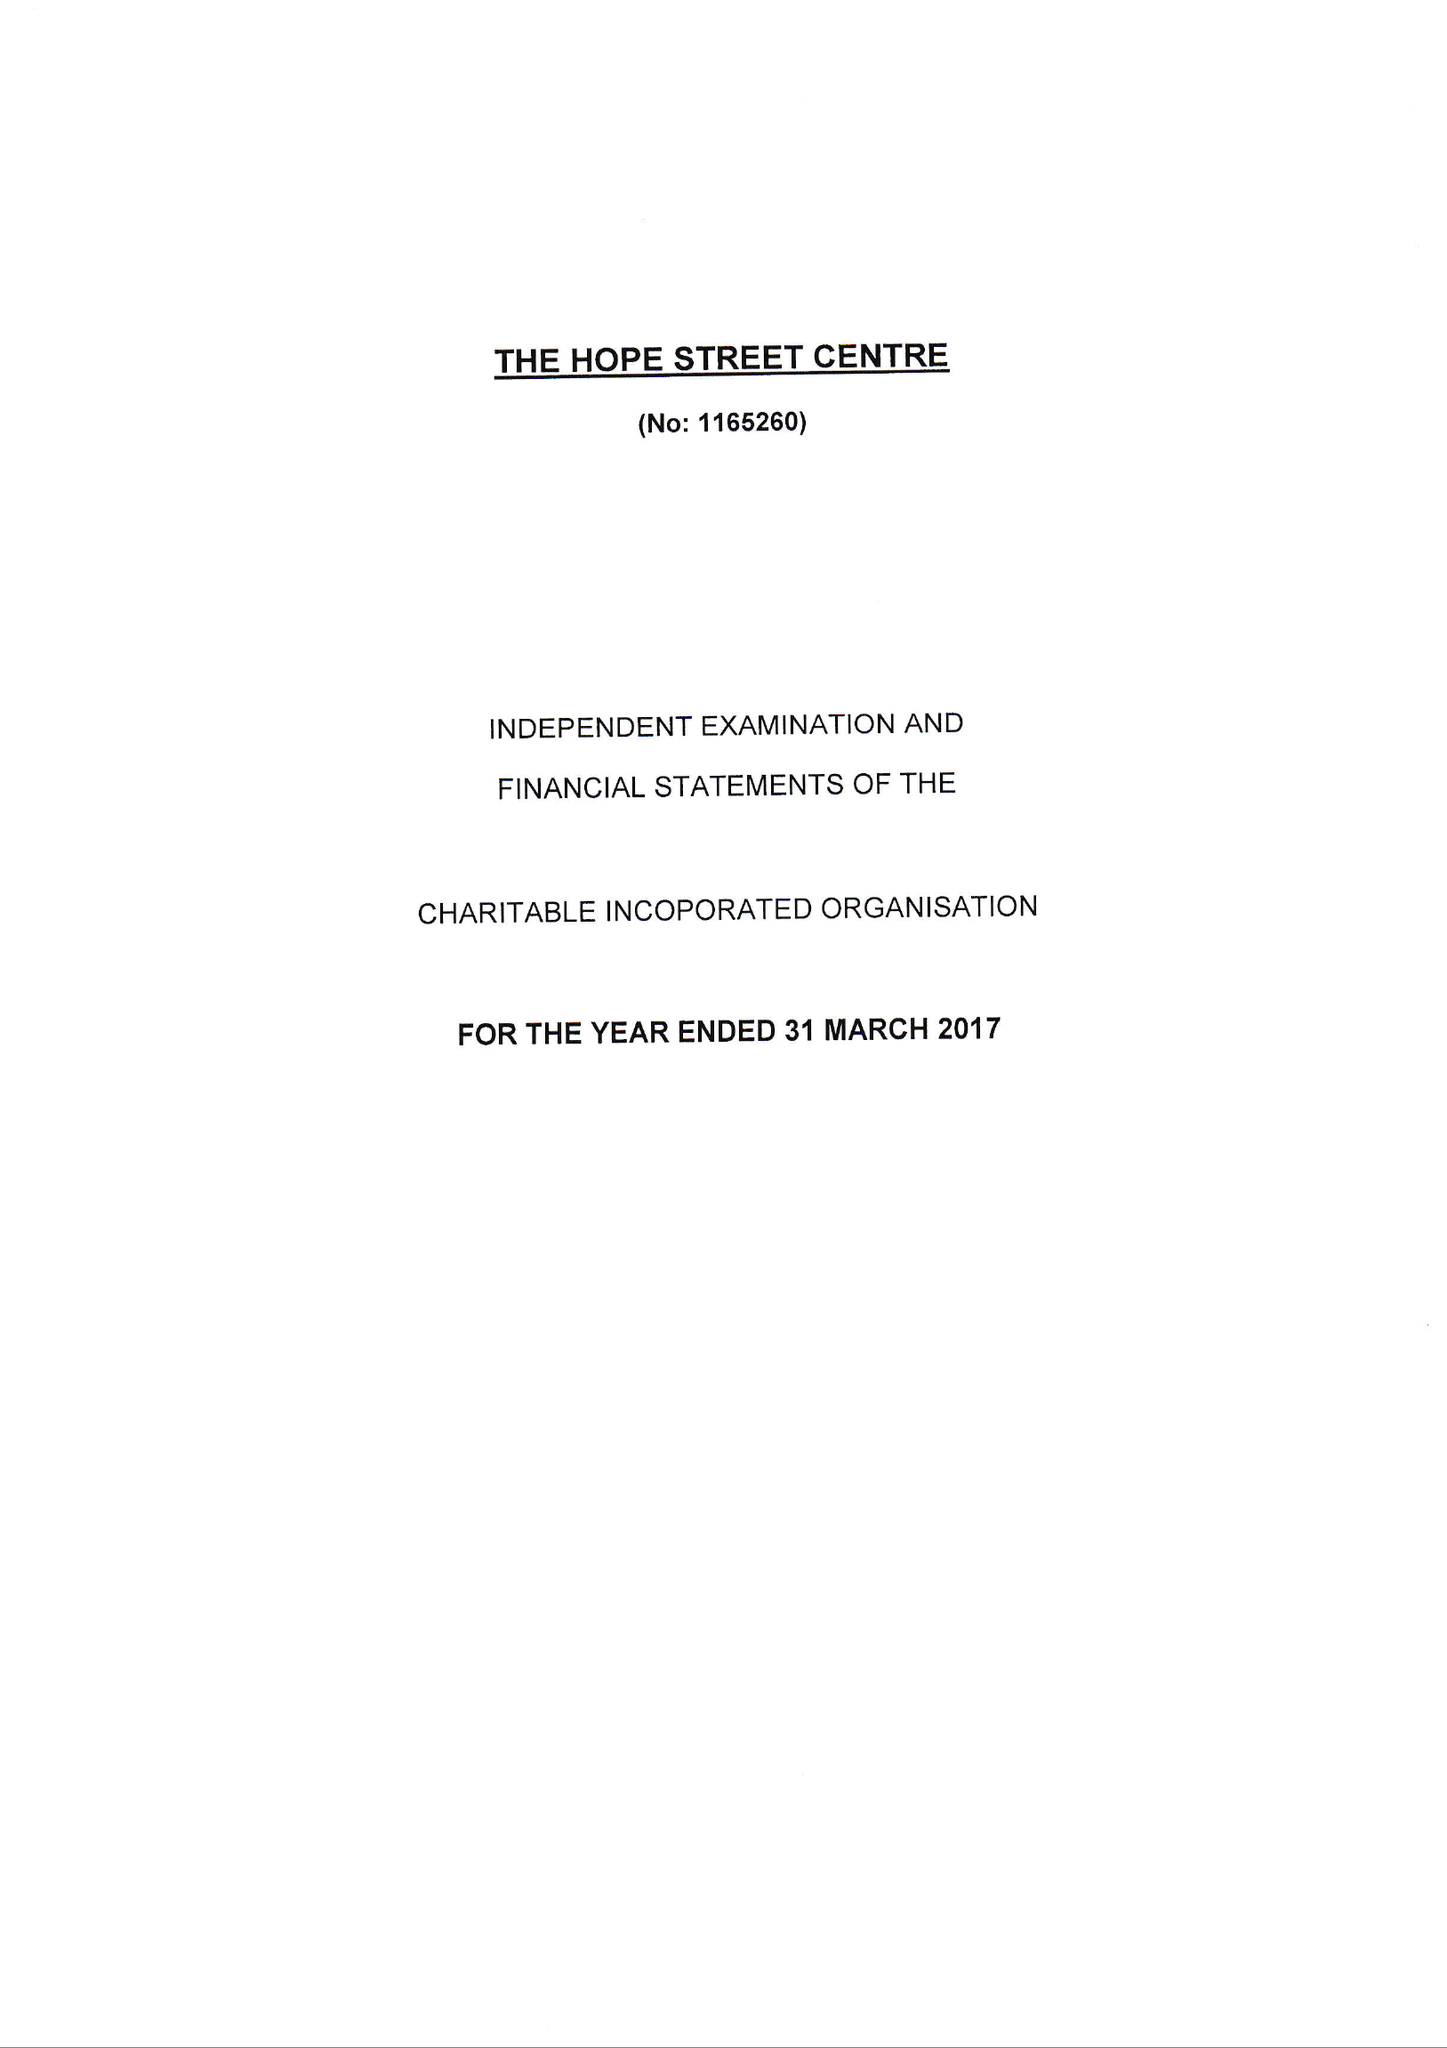What is the value for the address__post_town?
Answer the question using a single word or phrase. SHEERNESS 